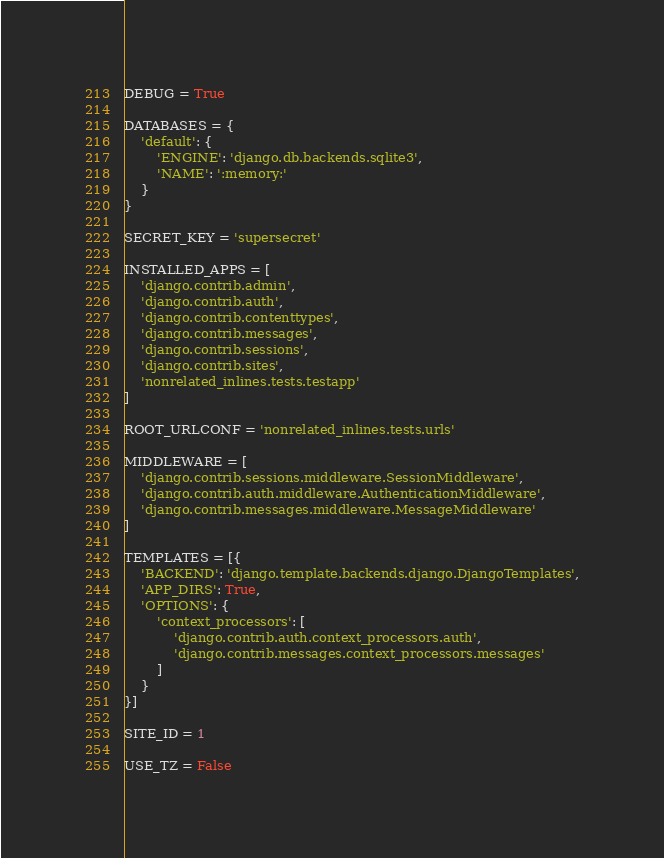<code> <loc_0><loc_0><loc_500><loc_500><_Python_>DEBUG = True

DATABASES = {
    'default': {
        'ENGINE': 'django.db.backends.sqlite3',
        'NAME': ':memory:'
    }
}

SECRET_KEY = 'supersecret'

INSTALLED_APPS = [
    'django.contrib.admin',
    'django.contrib.auth',
    'django.contrib.contenttypes',
    'django.contrib.messages',
    'django.contrib.sessions',
    'django.contrib.sites',
    'nonrelated_inlines.tests.testapp'
]

ROOT_URLCONF = 'nonrelated_inlines.tests.urls'

MIDDLEWARE = [
    'django.contrib.sessions.middleware.SessionMiddleware',
    'django.contrib.auth.middleware.AuthenticationMiddleware',
    'django.contrib.messages.middleware.MessageMiddleware'
]

TEMPLATES = [{
    'BACKEND': 'django.template.backends.django.DjangoTemplates',
    'APP_DIRS': True,
    'OPTIONS': {
        'context_processors': [
            'django.contrib.auth.context_processors.auth',
            'django.contrib.messages.context_processors.messages'
        ]
    }
}]

SITE_ID = 1

USE_TZ = False
</code> 